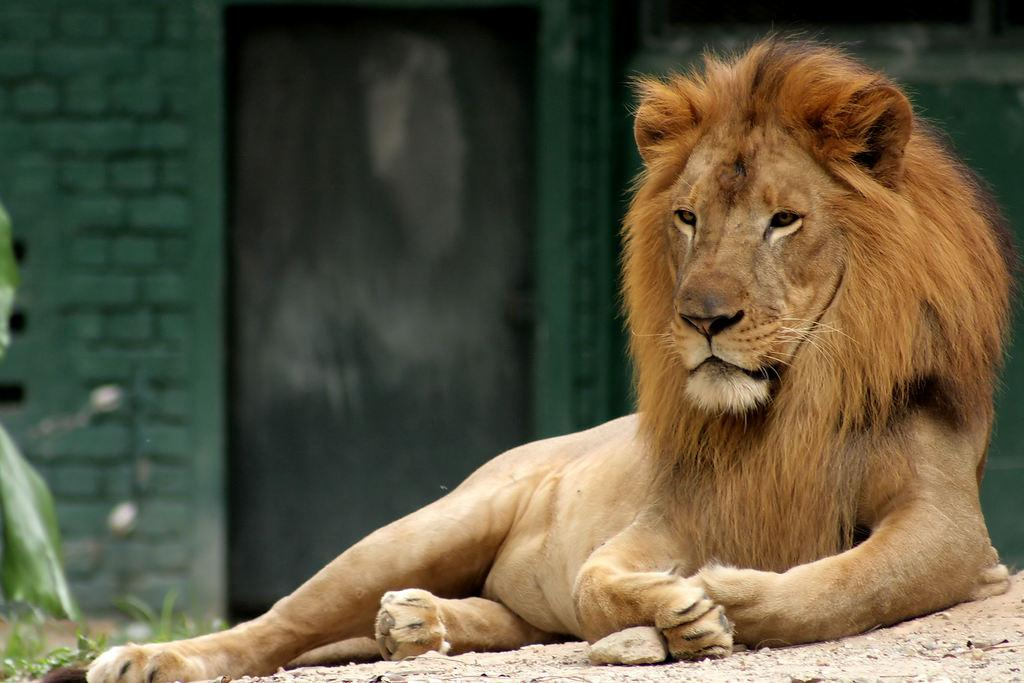What animal is sitting on the ground in the image? There is a lion sitting on the ground in the image. What can be seen in the background of the image? There is a door and a wall in the background of the image. What is located on the left side of the image? There is a plant on the left side of the image. What type of metal vest is the lion wearing in the image? There is no metal vest present in the image; the lion is not wearing any clothing. 